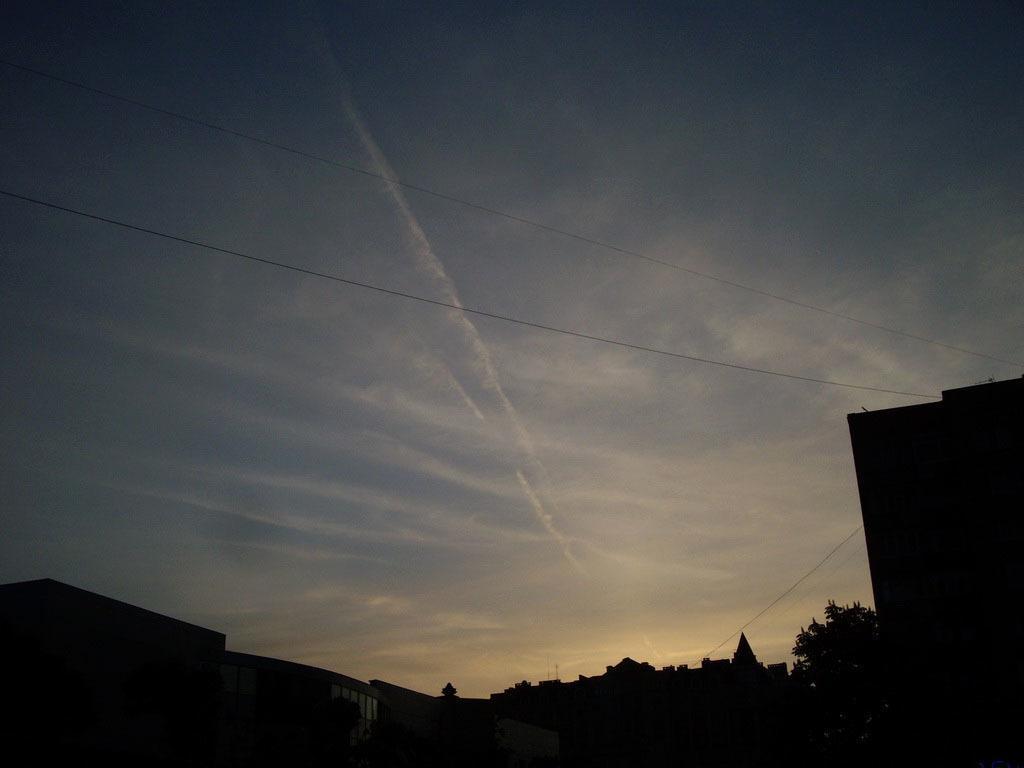Please provide a concise description of this image. In this image we can see sky with clouds. Also there are trees and buildings. And the image is looking dark. 